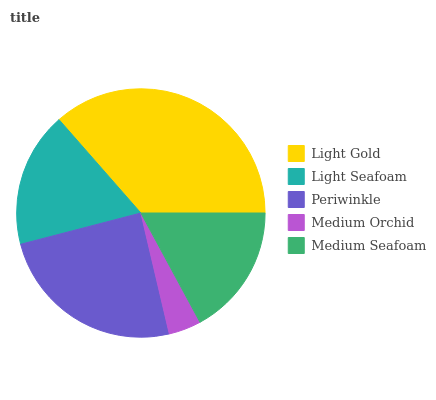Is Medium Orchid the minimum?
Answer yes or no. Yes. Is Light Gold the maximum?
Answer yes or no. Yes. Is Light Seafoam the minimum?
Answer yes or no. No. Is Light Seafoam the maximum?
Answer yes or no. No. Is Light Gold greater than Light Seafoam?
Answer yes or no. Yes. Is Light Seafoam less than Light Gold?
Answer yes or no. Yes. Is Light Seafoam greater than Light Gold?
Answer yes or no. No. Is Light Gold less than Light Seafoam?
Answer yes or no. No. Is Light Seafoam the high median?
Answer yes or no. Yes. Is Light Seafoam the low median?
Answer yes or no. Yes. Is Periwinkle the high median?
Answer yes or no. No. Is Medium Orchid the low median?
Answer yes or no. No. 